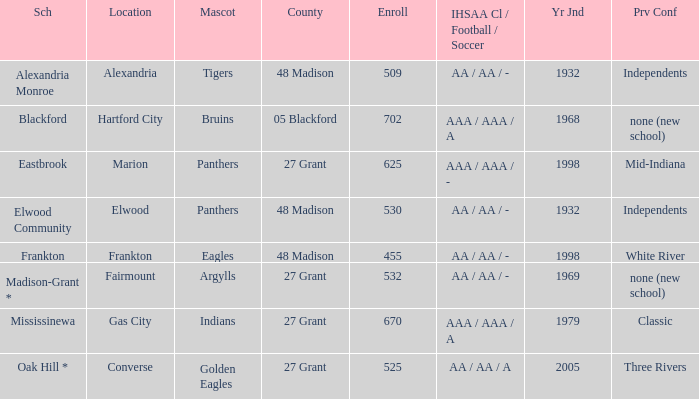What is the school with the location of alexandria? Alexandria Monroe. 